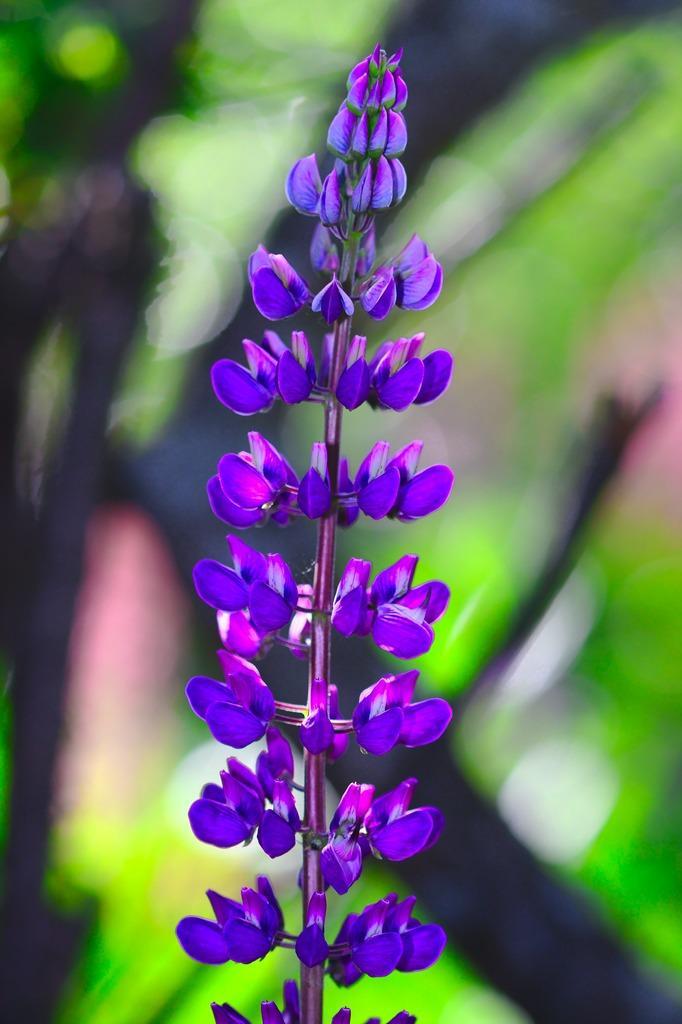How would you summarize this image in a sentence or two? In the picture I can see violet color flowers of a plant. The background of the image is blurred, which is in green color. 